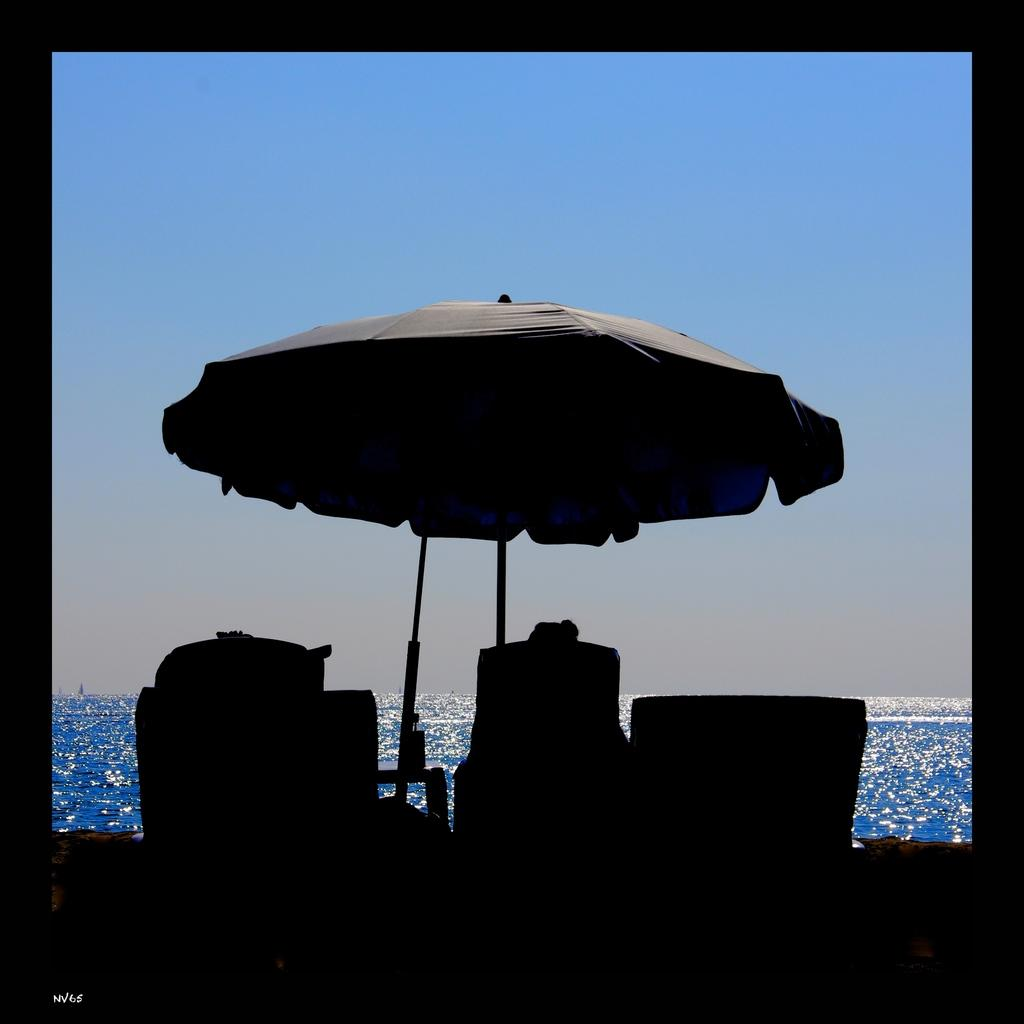How has the image been altered or modified? The image is edited. What object is present in the image that can provide shade or protection from rain? There is an umbrella with a pole in the image. What type of furniture can be seen in the image? There are chairs in the image. What natural element is visible in the image? There is water visible in the image. What is present in the bottom left corner of the image? There is a watermark in the bottom left corner of the image. What is visible in the background of the image? The sky is visible in the background of the image. What type of garden can be seen in the aftermath of the image? There is no garden present in the image, nor is there any indication of an aftermath. 